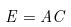<formula> <loc_0><loc_0><loc_500><loc_500>E = A C</formula> 